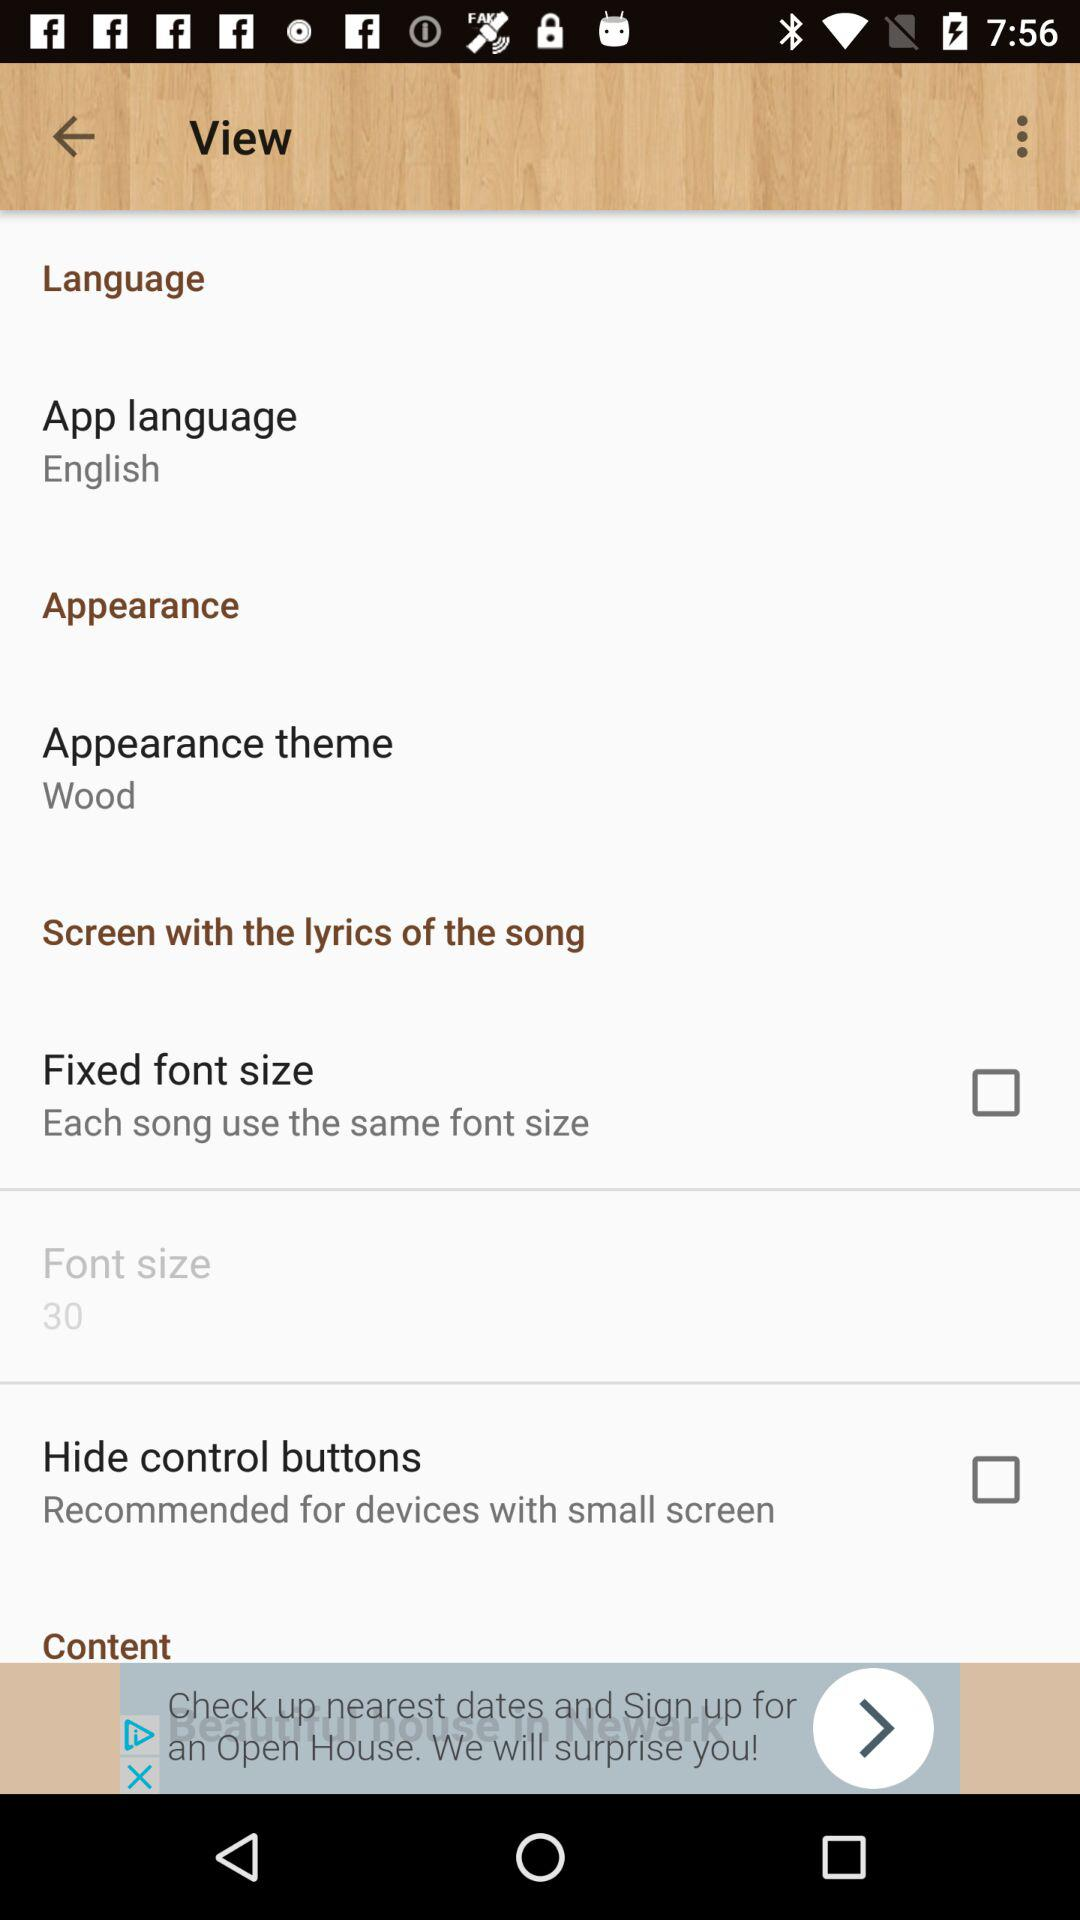What is the app language? The app language is English. 